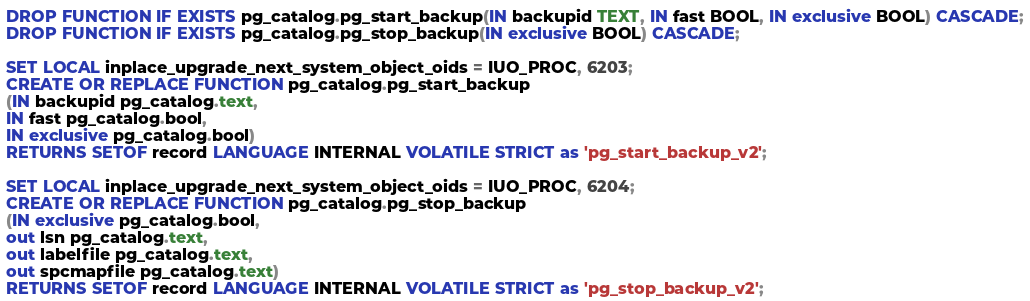<code> <loc_0><loc_0><loc_500><loc_500><_SQL_>DROP FUNCTION IF EXISTS pg_catalog.pg_start_backup(IN backupid TEXT, IN fast BOOL, IN exclusive BOOL) CASCADE;
DROP FUNCTION IF EXISTS pg_catalog.pg_stop_backup(IN exclusive BOOL) CASCADE;

SET LOCAL inplace_upgrade_next_system_object_oids = IUO_PROC, 6203;
CREATE OR REPLACE FUNCTION pg_catalog.pg_start_backup
(IN backupid pg_catalog.text,
IN fast pg_catalog.bool,
IN exclusive pg_catalog.bool)
RETURNS SETOF record LANGUAGE INTERNAL VOLATILE STRICT as 'pg_start_backup_v2';

SET LOCAL inplace_upgrade_next_system_object_oids = IUO_PROC, 6204;
CREATE OR REPLACE FUNCTION pg_catalog.pg_stop_backup
(IN exclusive pg_catalog.bool,
out lsn pg_catalog.text,
out labelfile pg_catalog.text,
out spcmapfile pg_catalog.text)
RETURNS SETOF record LANGUAGE INTERNAL VOLATILE STRICT as 'pg_stop_backup_v2';
</code> 